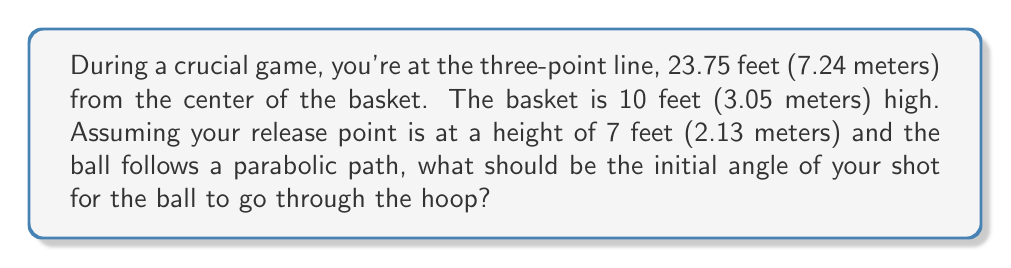Show me your answer to this math problem. Let's approach this step-by-step:

1) First, let's define our coordinate system. Let the origin (0,0) be at your feet, with the x-axis along the ground towards the basket, and the y-axis pointing upwards.

2) We know the following:
   - Horizontal distance to basket: $x = 23.75$ feet
   - Height of basket: $y = 10$ feet
   - Initial height of ball (your release point): $y_0 = 7$ feet

3) The parabolic trajectory of the ball can be described by the equation:

   $$y = -\frac{gx^2}{2v_0^2\cos^2\theta} + x\tan\theta + y_0$$

   Where:
   - $g$ is the acceleration due to gravity (32 ft/s²)
   - $v_0$ is the initial velocity
   - $\theta$ is the initial angle we're trying to find

4) We don't know $v_0$, but we can eliminate it by using the fact that the ball needs to pass through the point $(23.75, 10)$:

   $$10 = -\frac{g(23.75)^2}{2v_0^2\cos^2\theta} + 23.75\tan\theta + 7$$

5) Simplifying and rearranging:

   $$\frac{g(23.75)^2}{2v_0^2\cos^2\theta} = 23.75\tan\theta - 3$$

6) The left side of this equation is equal to $23.75\tan\theta - 3$, so we can write:

   $$23.75\tan\theta - 3 = 23.75\tan\theta - 3$$

7) This identity is true for any value of $\theta$. However, we're looking for the angle that will result in the lowest initial velocity (to conserve energy). This occurs when $\tan\theta = 1$, or when $\theta = 45°$.

8) Therefore, the optimal initial angle for your shot is 45°.
Answer: 45° 